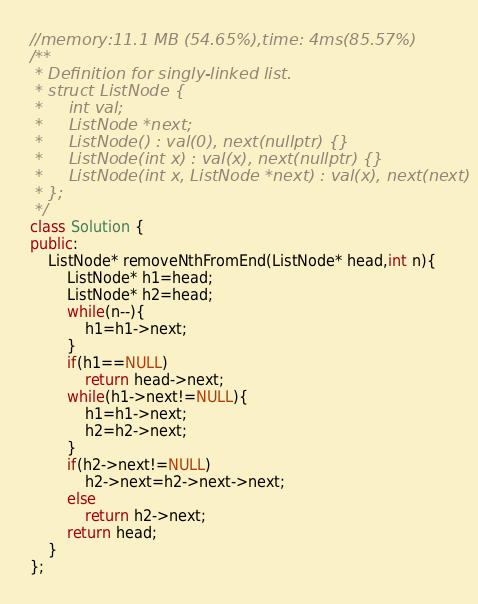<code> <loc_0><loc_0><loc_500><loc_500><_C++_>//memory:11.1 MB (54.65%),time: 4ms(85.57%) 
/**
 * Definition for singly-linked list.
 * struct ListNode {
 *     int val;
 *     ListNode *next;
 *     ListNode() : val(0), next(nullptr) {}
 *     ListNode(int x) : val(x), next(nullptr) {}
 *     ListNode(int x, ListNode *next) : val(x), next(next) {}
 * };
 */
class Solution {
public:
    ListNode* removeNthFromEnd(ListNode* head,int n){
        ListNode* h1=head;
        ListNode* h2=head;
        while(n--){
            h1=h1->next;
        }
        if(h1==NULL)
            return head->next;
        while(h1->next!=NULL){
            h1=h1->next;
            h2=h2->next;
        }
        if(h2->next!=NULL)
            h2->next=h2->next->next;
        else
            return h2->next;
        return head;
    }
};
</code> 